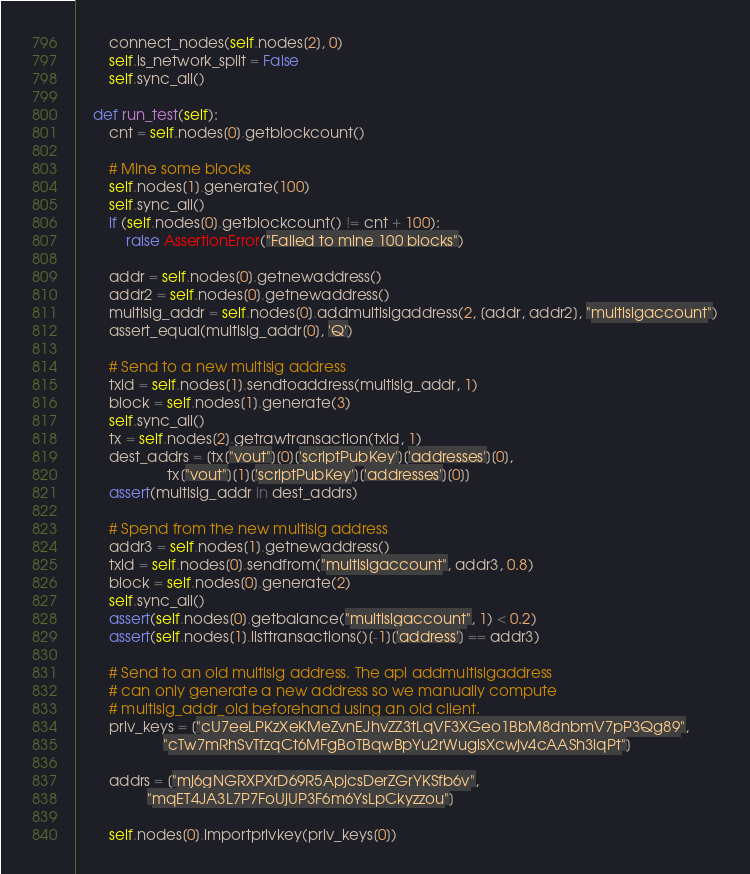Convert code to text. <code><loc_0><loc_0><loc_500><loc_500><_Python_>        connect_nodes(self.nodes[2], 0)
        self.is_network_split = False
        self.sync_all()

    def run_test(self):
        cnt = self.nodes[0].getblockcount()

        # Mine some blocks
        self.nodes[1].generate(100)
        self.sync_all()
        if (self.nodes[0].getblockcount() != cnt + 100):
            raise AssertionError("Failed to mine 100 blocks")

        addr = self.nodes[0].getnewaddress()
        addr2 = self.nodes[0].getnewaddress()
        multisig_addr = self.nodes[0].addmultisigaddress(2, [addr, addr2], "multisigaccount")
        assert_equal(multisig_addr[0], 'Q')

        # Send to a new multisig address
        txid = self.nodes[1].sendtoaddress(multisig_addr, 1)
        block = self.nodes[1].generate(3)
        self.sync_all()
        tx = self.nodes[2].getrawtransaction(txid, 1)
        dest_addrs = [tx["vout"][0]['scriptPubKey']['addresses'][0],
                      tx["vout"][1]['scriptPubKey']['addresses'][0]]
        assert(multisig_addr in dest_addrs)

        # Spend from the new multisig address
        addr3 = self.nodes[1].getnewaddress()
        txid = self.nodes[0].sendfrom("multisigaccount", addr3, 0.8)
        block = self.nodes[0].generate(2)
        self.sync_all()
        assert(self.nodes[0].getbalance("multisigaccount", 1) < 0.2)
        assert(self.nodes[1].listtransactions()[-1]['address'] == addr3)

        # Send to an old multisig address. The api addmultisigaddress
        # can only generate a new address so we manually compute
        # multisig_addr_old beforehand using an old client.
        priv_keys = ["cU7eeLPKzXeKMeZvnEJhvZZ3tLqVF3XGeo1BbM8dnbmV7pP3Qg89",
                     "cTw7mRhSvTfzqCt6MFgBoTBqwBpYu2rWugisXcwjv4cAASh3iqPt"]

        addrs = ["mj6gNGRXPXrD69R5ApjcsDerZGrYKSfb6v",
                 "mqET4JA3L7P7FoUjUP3F6m6YsLpCkyzzou"]

        self.nodes[0].importprivkey(priv_keys[0])</code> 